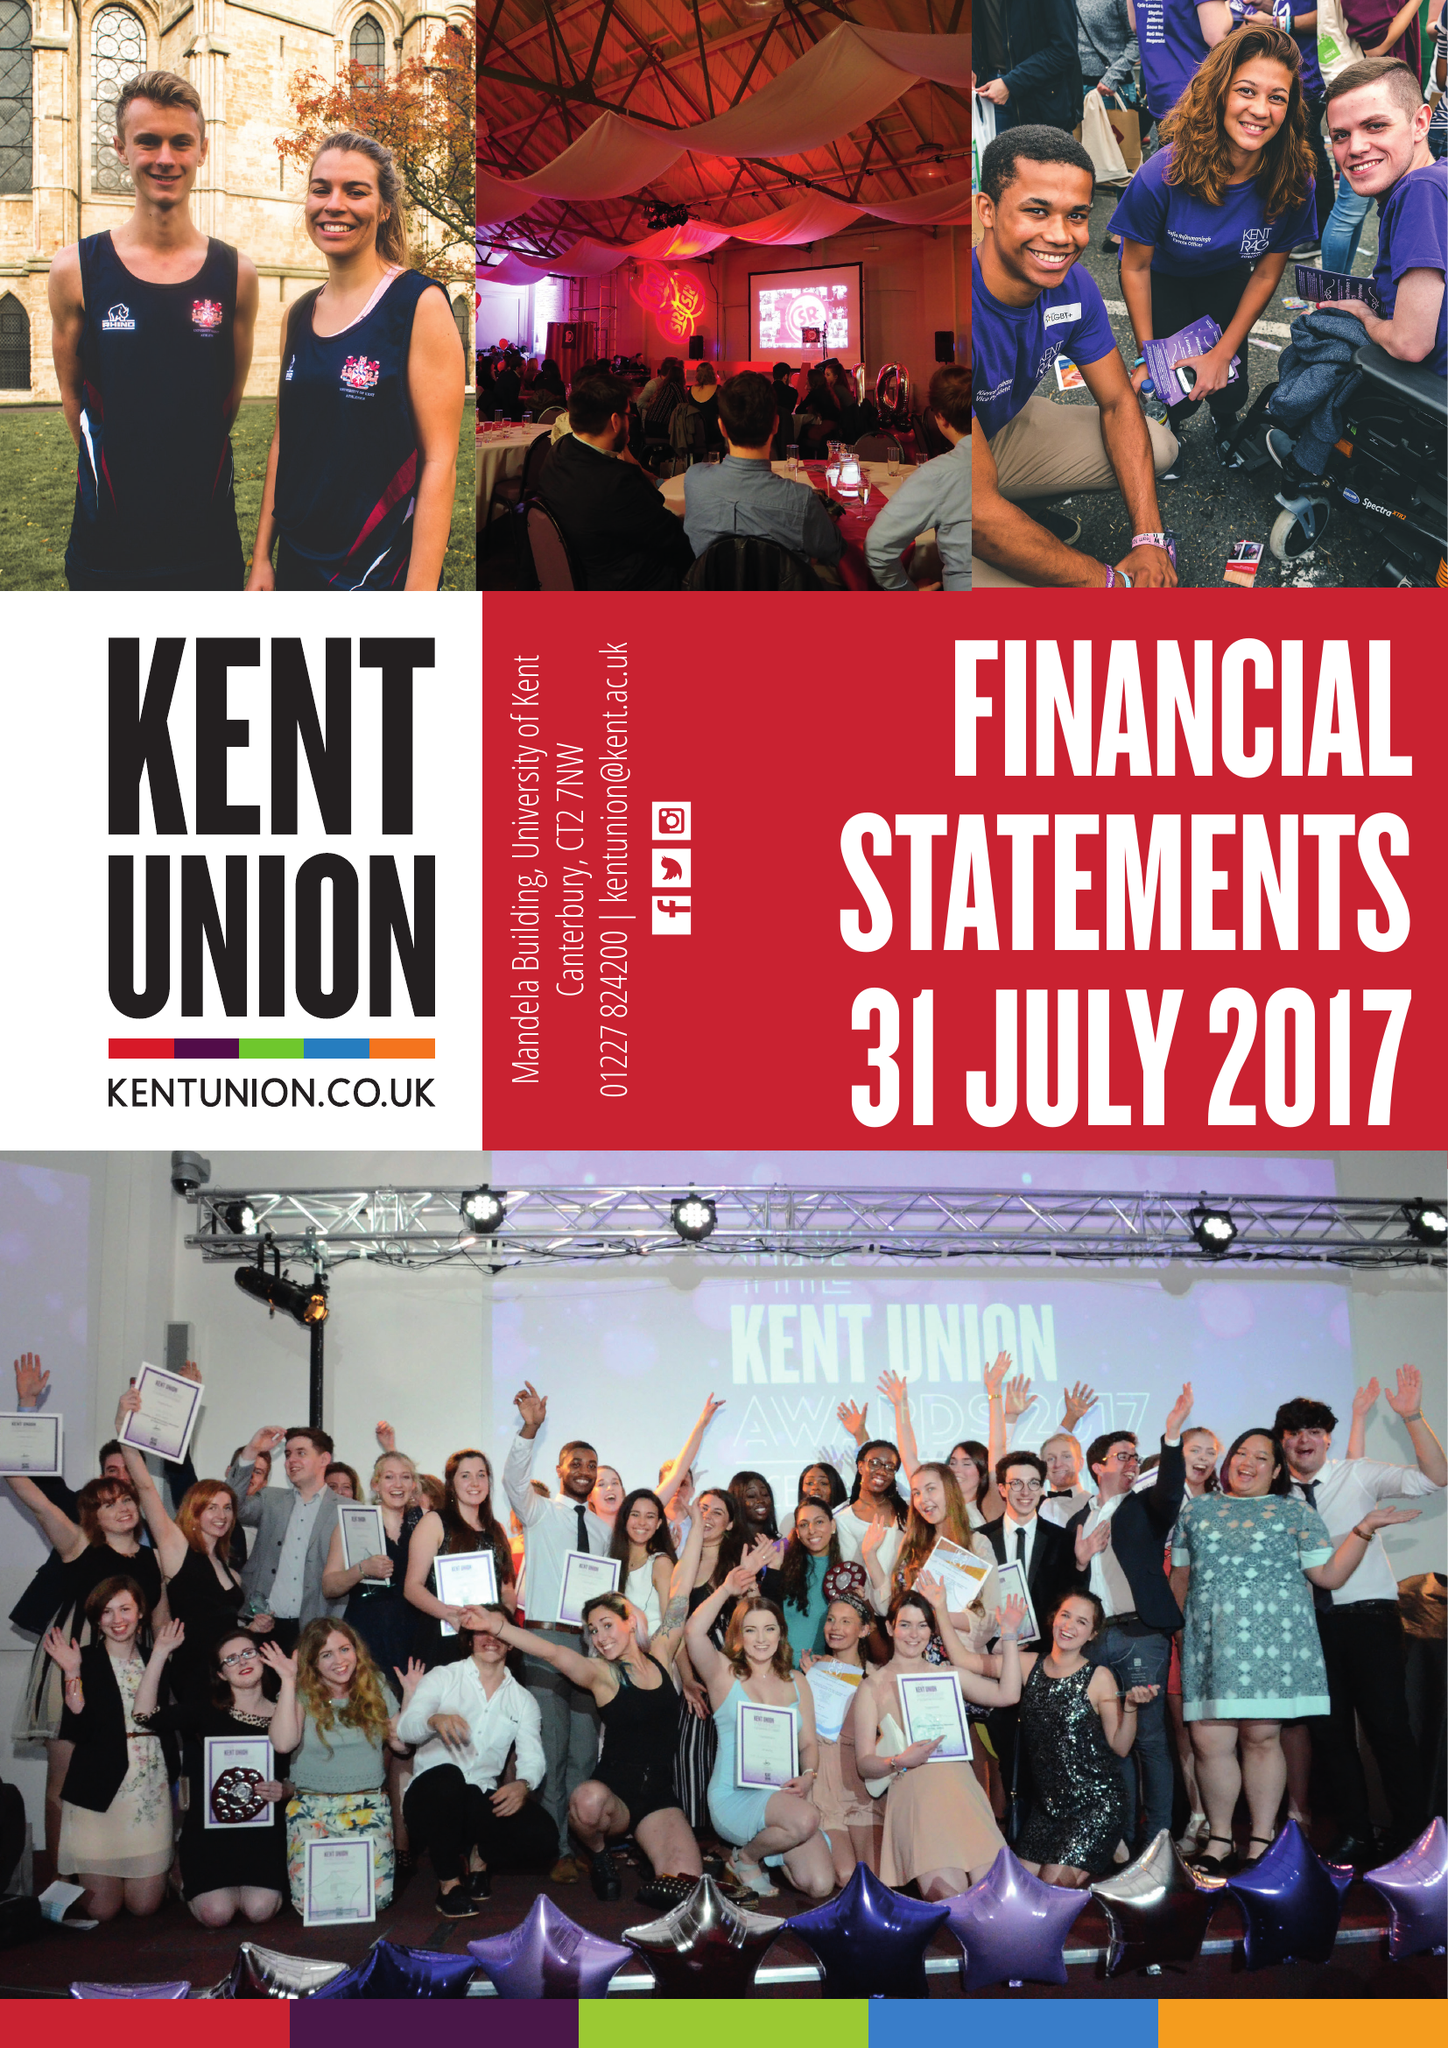What is the value for the address__street_line?
Answer the question using a single word or phrase. CANTERBURY 